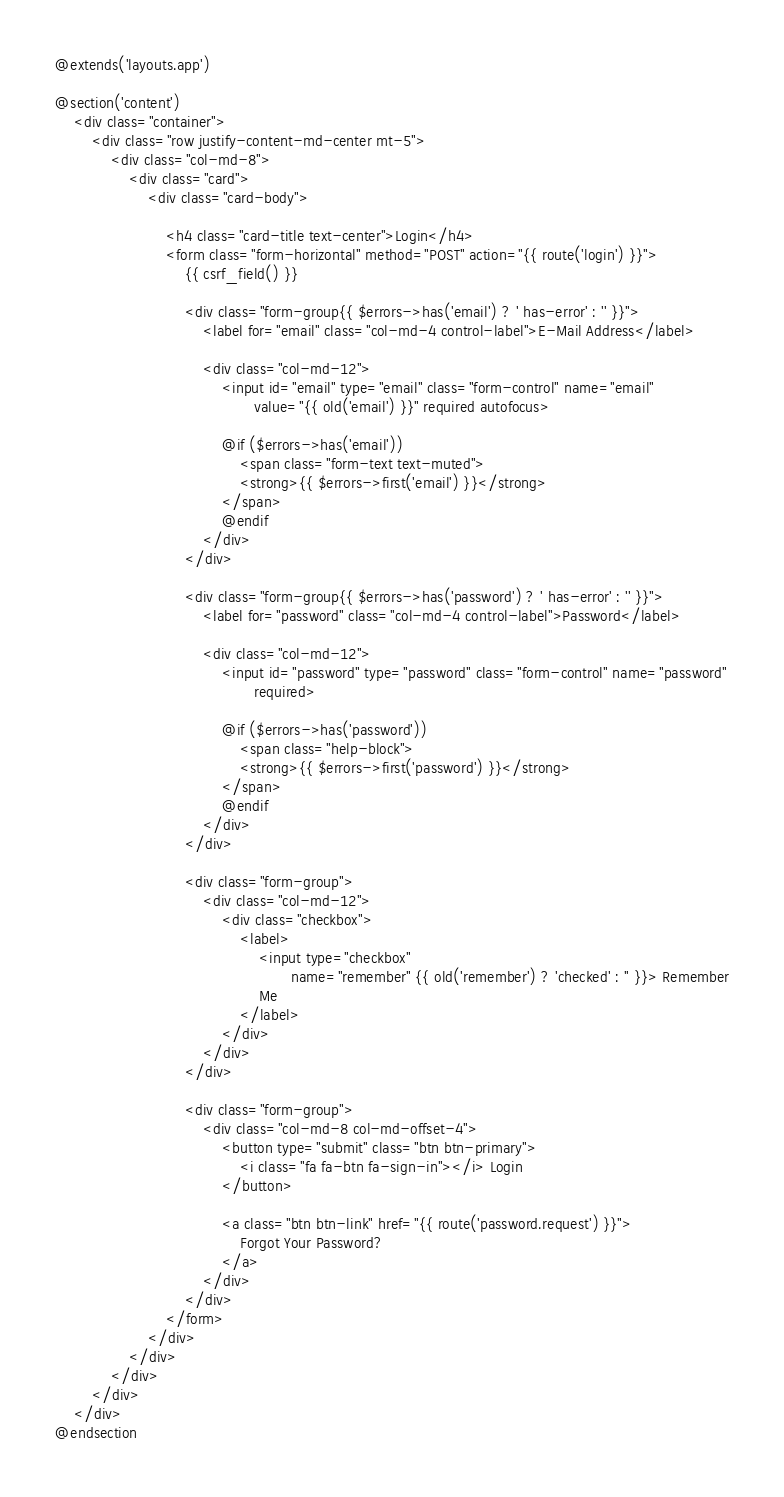Convert code to text. <code><loc_0><loc_0><loc_500><loc_500><_PHP_>@extends('layouts.app')

@section('content')
    <div class="container">
        <div class="row justify-content-md-center mt-5">
            <div class="col-md-8">
                <div class="card">
                    <div class="card-body">

                        <h4 class="card-title text-center">Login</h4>
                        <form class="form-horizontal" method="POST" action="{{ route('login') }}">
                            {{ csrf_field() }}

                            <div class="form-group{{ $errors->has('email') ? ' has-error' : '' }}">
                                <label for="email" class="col-md-4 control-label">E-Mail Address</label>

                                <div class="col-md-12">
                                    <input id="email" type="email" class="form-control" name="email"
                                           value="{{ old('email') }}" required autofocus>

                                    @if ($errors->has('email'))
                                        <span class="form-text text-muted">
                                        <strong>{{ $errors->first('email') }}</strong>
                                    </span>
                                    @endif
                                </div>
                            </div>

                            <div class="form-group{{ $errors->has('password') ? ' has-error' : '' }}">
                                <label for="password" class="col-md-4 control-label">Password</label>

                                <div class="col-md-12">
                                    <input id="password" type="password" class="form-control" name="password"
                                           required>

                                    @if ($errors->has('password'))
                                        <span class="help-block">
                                        <strong>{{ $errors->first('password') }}</strong>
                                    </span>
                                    @endif
                                </div>
                            </div>

                            <div class="form-group">
                                <div class="col-md-12">
                                    <div class="checkbox">
                                        <label>
                                            <input type="checkbox"
                                                   name="remember" {{ old('remember') ? 'checked' : '' }}> Remember
                                            Me
                                        </label>
                                    </div>
                                </div>
                            </div>

                            <div class="form-group">
                                <div class="col-md-8 col-md-offset-4">
                                    <button type="submit" class="btn btn-primary">
                                        <i class="fa fa-btn fa-sign-in"></i> Login
                                    </button>

                                    <a class="btn btn-link" href="{{ route('password.request') }}">
                                        Forgot Your Password?
                                    </a>
                                </div>
                            </div>
                        </form>
                    </div>
                </div>
            </div>
        </div>
    </div>
@endsection
</code> 